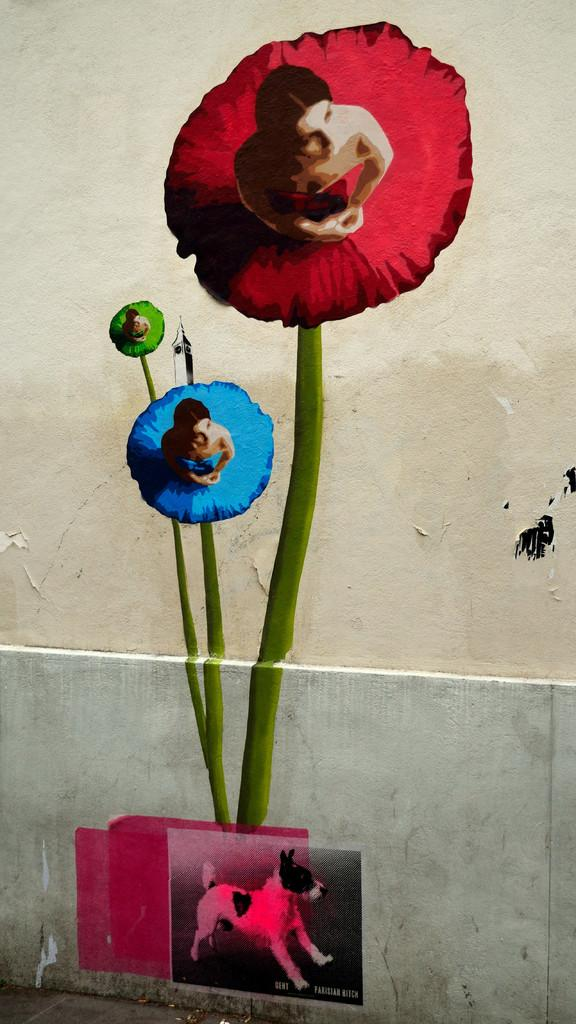What is hanging on the wall in the image? There is a painting on the wall in the image. What type of animal is present in the image? There is a dog in the image. Who else is present in the image besides the dog? There is a woman in the image. What type of potato is being held by the woman in the image? There is no potato present in the image; the woman is not holding anything. How many berries can be seen on the dog in the image? There are no berries present in the image; the dog is not associated with any berries. 